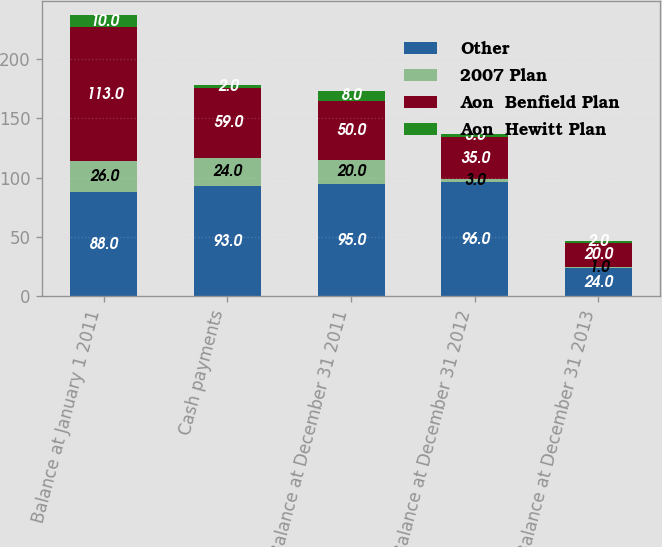Convert chart to OTSL. <chart><loc_0><loc_0><loc_500><loc_500><stacked_bar_chart><ecel><fcel>Balance at January 1 2011<fcel>Cash payments<fcel>Balance at December 31 2011<fcel>Balance at December 31 2012<fcel>Balance at December 31 2013<nl><fcel>Other<fcel>88<fcel>93<fcel>95<fcel>96<fcel>24<nl><fcel>2007 Plan<fcel>26<fcel>24<fcel>20<fcel>3<fcel>1<nl><fcel>Aon  Benfield Plan<fcel>113<fcel>59<fcel>50<fcel>35<fcel>20<nl><fcel>Aon  Hewitt Plan<fcel>10<fcel>2<fcel>8<fcel>3<fcel>2<nl></chart> 